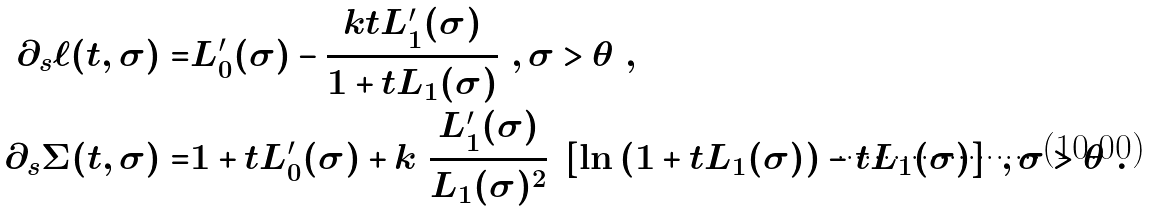Convert formula to latex. <formula><loc_0><loc_0><loc_500><loc_500>\partial _ { s } \ell ( t , \sigma ) = & L _ { 0 } ^ { \prime } ( \sigma ) - \frac { k t L _ { 1 } ^ { \prime } ( \sigma ) } { 1 + t L _ { 1 } ( \sigma ) } \ , \sigma > \theta \ , \\ \partial _ { s } \Sigma ( t , \sigma ) = & 1 + t L _ { 0 } ^ { \prime } ( \sigma ) + k \ \frac { L _ { 1 } ^ { \prime } ( \sigma ) } { L _ { 1 } ( \sigma ) ^ { 2 } } \ \left [ \ln { ( 1 + t L _ { 1 } ( \sigma ) ) } - t L _ { 1 } ( \sigma ) \right ] \ , \sigma > \theta \ .</formula> 